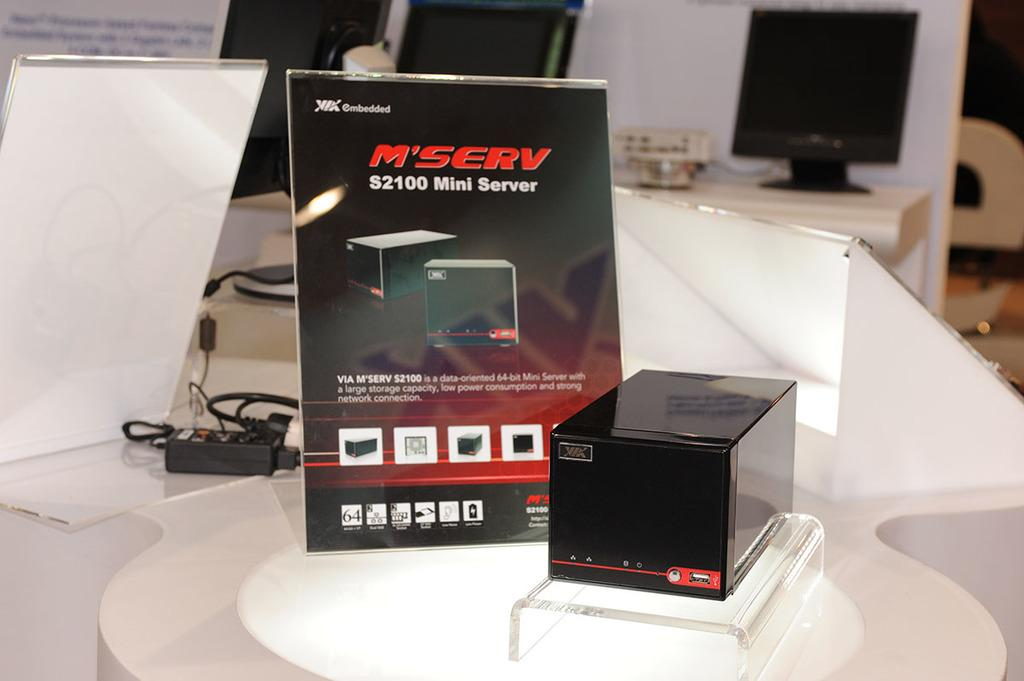<image>
Give a short and clear explanation of the subsequent image. black box called serv and the display sign 